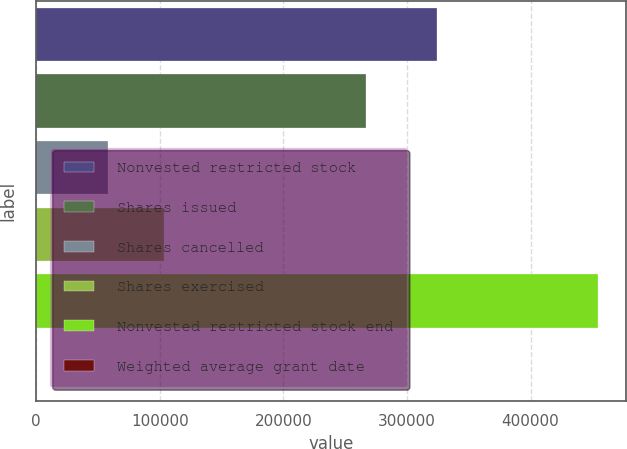Convert chart to OTSL. <chart><loc_0><loc_0><loc_500><loc_500><bar_chart><fcel>Nonvested restricted stock<fcel>Shares issued<fcel>Shares cancelled<fcel>Shares exercised<fcel>Nonvested restricted stock end<fcel>Weighted average grant date<nl><fcel>324289<fcel>267055<fcel>58086<fcel>103531<fcel>454484<fcel>34.77<nl></chart> 